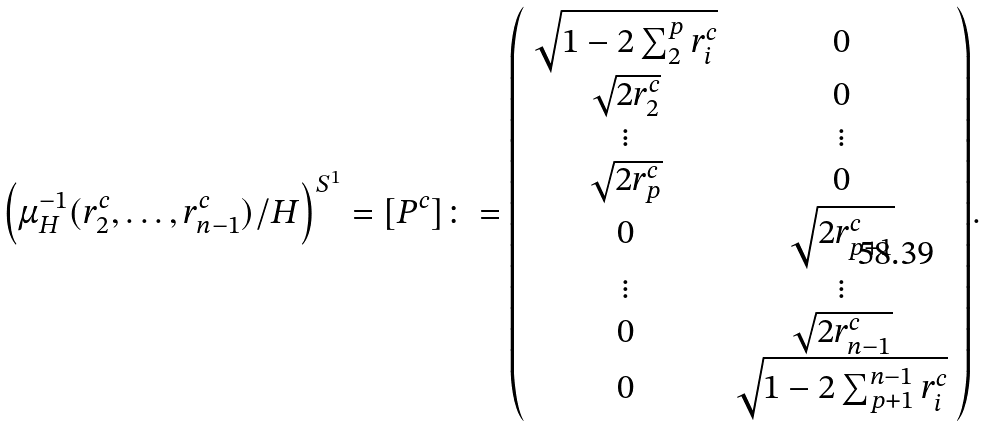Convert formula to latex. <formula><loc_0><loc_0><loc_500><loc_500>\left ( \mu _ { H } ^ { - 1 } ( r _ { 2 } ^ { c } , \dots , r _ { n - 1 } ^ { c } ) / H \right ) ^ { S ^ { 1 } } = [ P ^ { c } ] \colon = { \left ( \begin{array} { c c } \sqrt { 1 - 2 \sum _ { 2 } ^ { p } r _ { i } ^ { c } } & 0 \\ \sqrt { 2 r _ { 2 } ^ { c } } & 0 \\ \vdots & \vdots \\ \sqrt { 2 r _ { p } ^ { c } } & 0 \\ 0 & \sqrt { 2 r _ { p + 1 } ^ { c } } \\ \vdots & \vdots \\ 0 & \sqrt { 2 r _ { n - 1 } ^ { c } } \\ 0 & \sqrt { 1 - 2 \sum _ { p + 1 } ^ { n - 1 } r _ { i } ^ { c } } \end{array} \right ) } .</formula> 